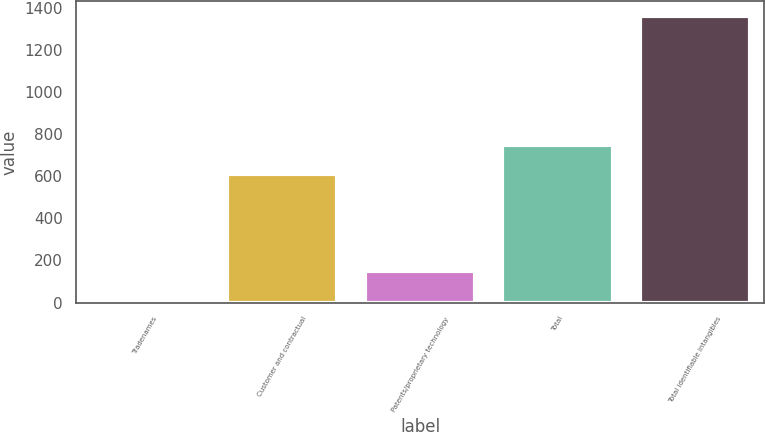Convert chart to OTSL. <chart><loc_0><loc_0><loc_500><loc_500><bar_chart><fcel>Tradenames<fcel>Customer and contractual<fcel>Patents/proprietary technology<fcel>Total<fcel>Total identifiable intangibles<nl><fcel>15.8<fcel>611.9<fcel>150.36<fcel>746.46<fcel>1361.4<nl></chart> 